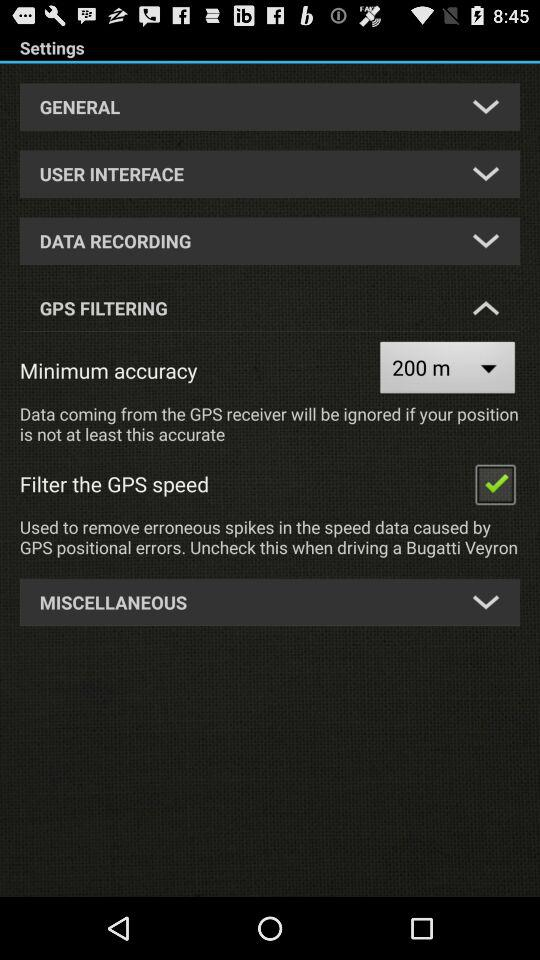Which is the minimum accuracy? The minimum accuracy is 200m. 